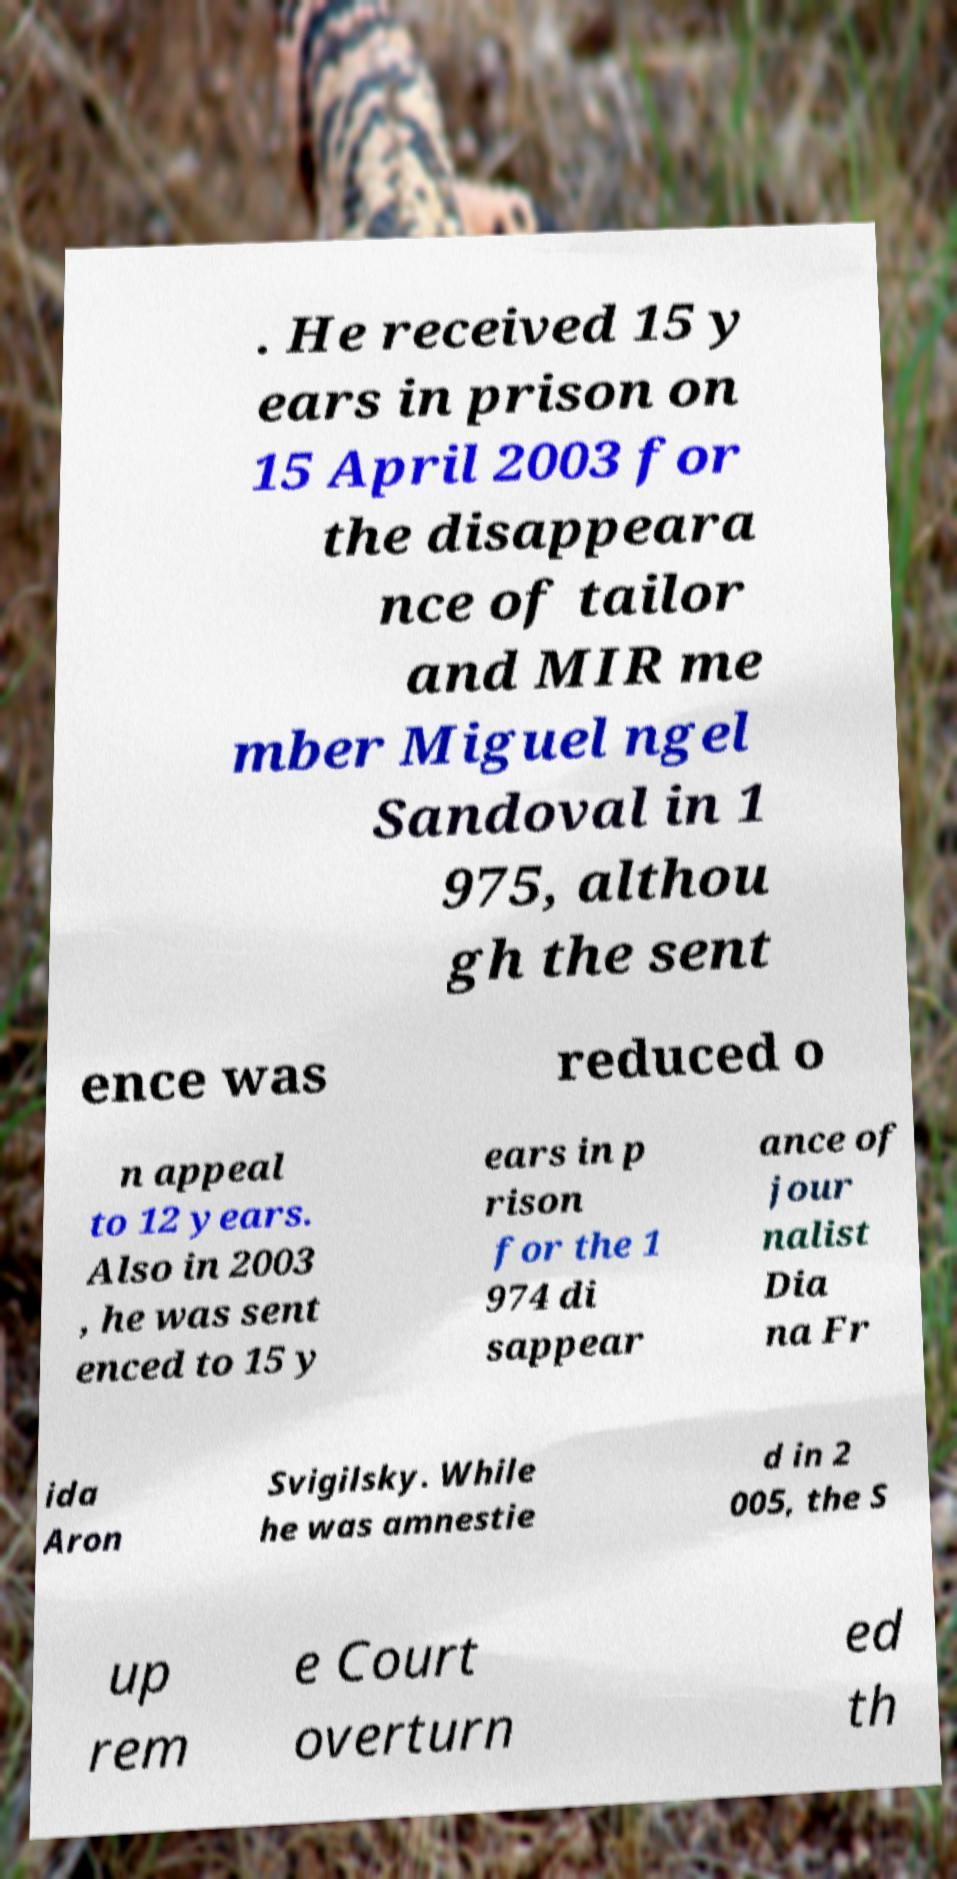What messages or text are displayed in this image? I need them in a readable, typed format. . He received 15 y ears in prison on 15 April 2003 for the disappeara nce of tailor and MIR me mber Miguel ngel Sandoval in 1 975, althou gh the sent ence was reduced o n appeal to 12 years. Also in 2003 , he was sent enced to 15 y ears in p rison for the 1 974 di sappear ance of jour nalist Dia na Fr ida Aron Svigilsky. While he was amnestie d in 2 005, the S up rem e Court overturn ed th 